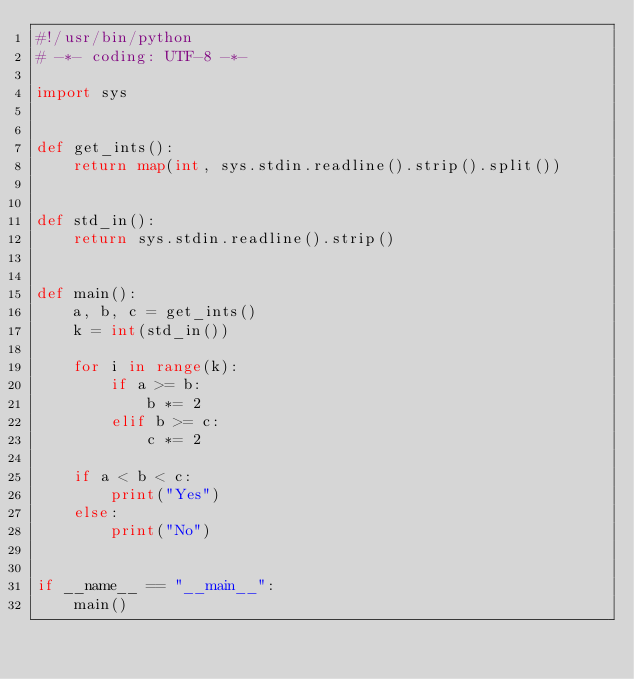<code> <loc_0><loc_0><loc_500><loc_500><_Python_>#!/usr/bin/python
# -*- coding: UTF-8 -*-

import sys


def get_ints():
    return map(int, sys.stdin.readline().strip().split())


def std_in():
    return sys.stdin.readline().strip()


def main():
    a, b, c = get_ints()
    k = int(std_in())

    for i in range(k):
        if a >= b:
            b *= 2
        elif b >= c:
            c *= 2

    if a < b < c:
        print("Yes")
    else:
        print("No")


if __name__ == "__main__":
    main()
</code> 